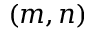Convert formula to latex. <formula><loc_0><loc_0><loc_500><loc_500>( m , n )</formula> 